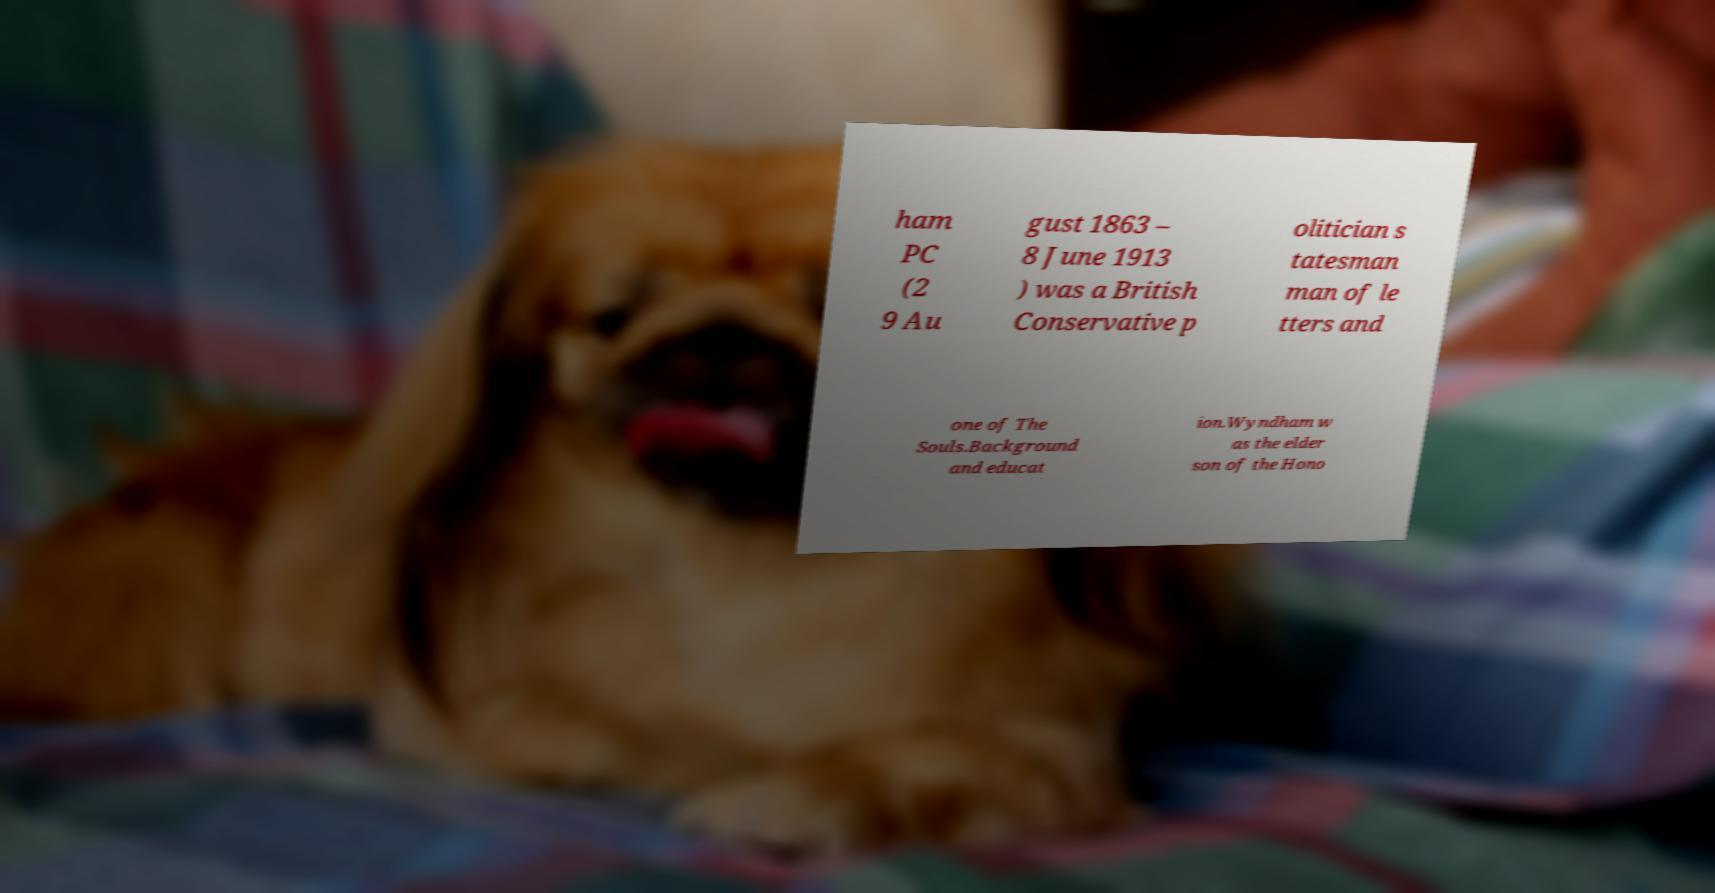Could you extract and type out the text from this image? ham PC (2 9 Au gust 1863 – 8 June 1913 ) was a British Conservative p olitician s tatesman man of le tters and one of The Souls.Background and educat ion.Wyndham w as the elder son of the Hono 